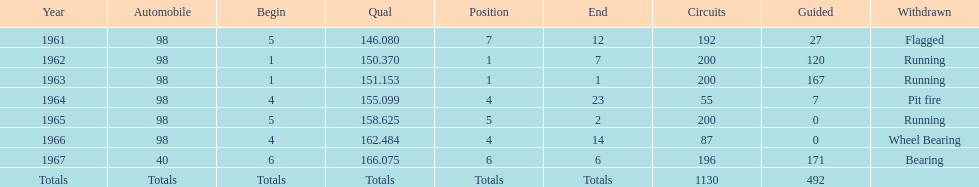How many times did he finish in the top three? 2. 